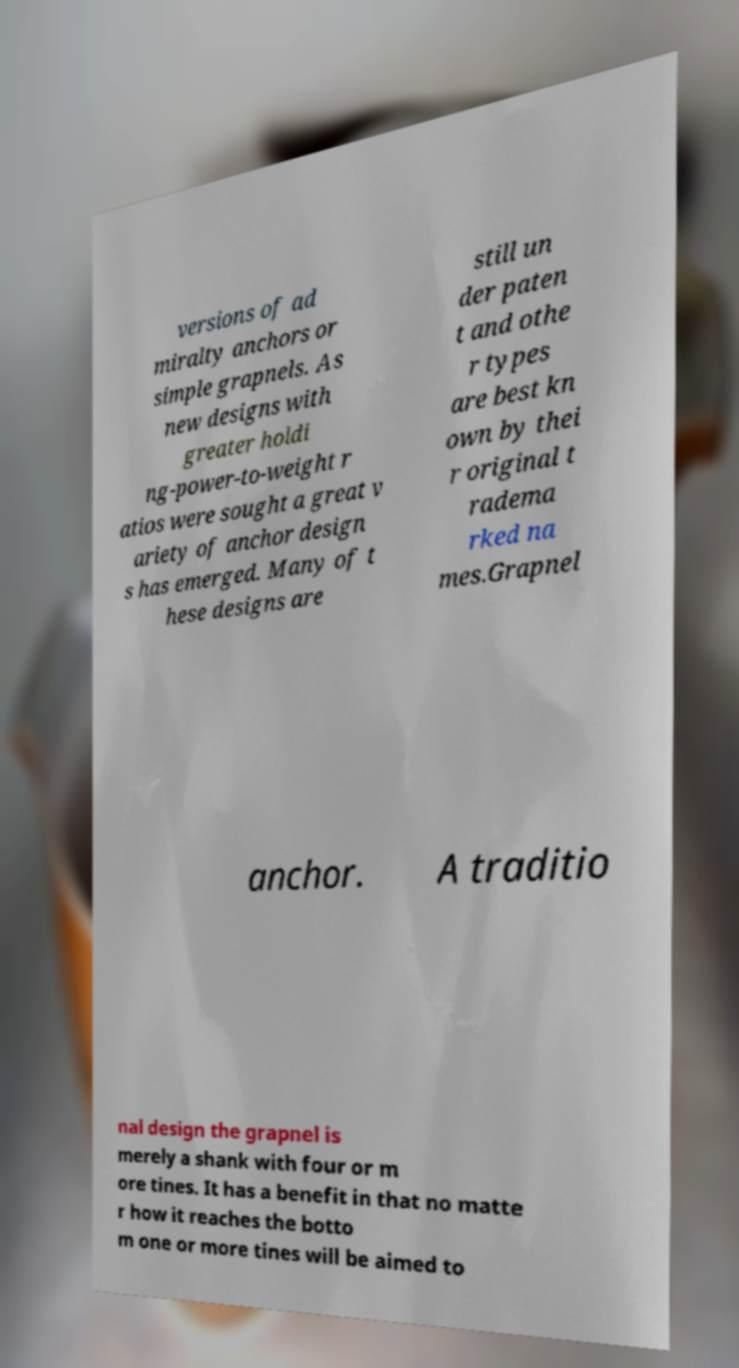Please identify and transcribe the text found in this image. versions of ad miralty anchors or simple grapnels. As new designs with greater holdi ng-power-to-weight r atios were sought a great v ariety of anchor design s has emerged. Many of t hese designs are still un der paten t and othe r types are best kn own by thei r original t radema rked na mes.Grapnel anchor. A traditio nal design the grapnel is merely a shank with four or m ore tines. It has a benefit in that no matte r how it reaches the botto m one or more tines will be aimed to 